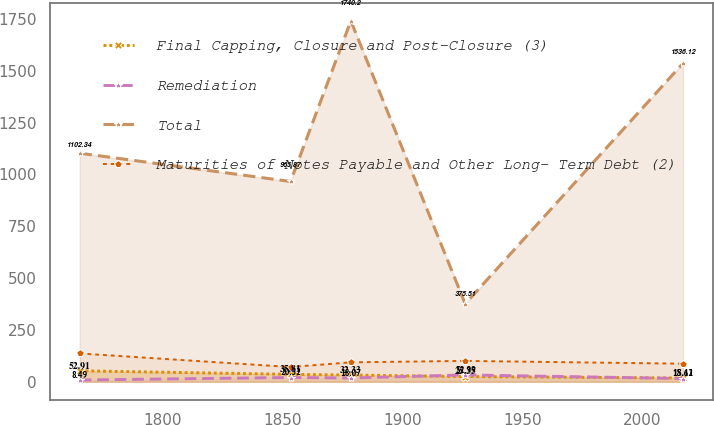Convert chart. <chart><loc_0><loc_0><loc_500><loc_500><line_chart><ecel><fcel>Final Capping, Closure and Post-Closure (3)<fcel>Remediation<fcel>Total<fcel>Maturities of Notes Payable and Other Long- Term Debt (2)<nl><fcel>1765.27<fcel>52.91<fcel>8.49<fcel>1102.34<fcel>136.59<nl><fcel>1853.23<fcel>35.81<fcel>20.52<fcel>965.87<fcel>71.13<nl><fcel>1878.4<fcel>32.33<fcel>18.07<fcel>1740.2<fcel>93.72<nl><fcel>1926.11<fcel>25.35<fcel>32.99<fcel>375.51<fcel>100.64<nl><fcel>2017<fcel>18.11<fcel>15.62<fcel>1536.12<fcel>87.17<nl></chart> 